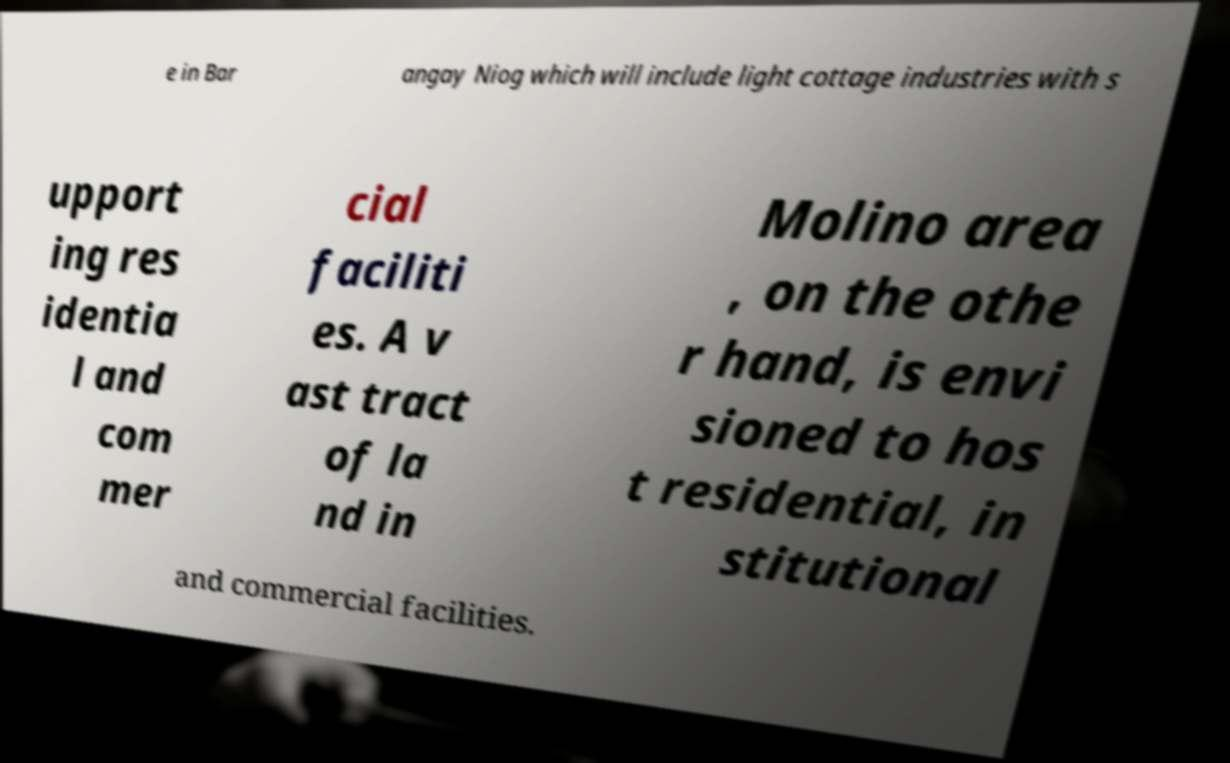Please read and relay the text visible in this image. What does it say? e in Bar angay Niog which will include light cottage industries with s upport ing res identia l and com mer cial faciliti es. A v ast tract of la nd in Molino area , on the othe r hand, is envi sioned to hos t residential, in stitutional and commercial facilities. 